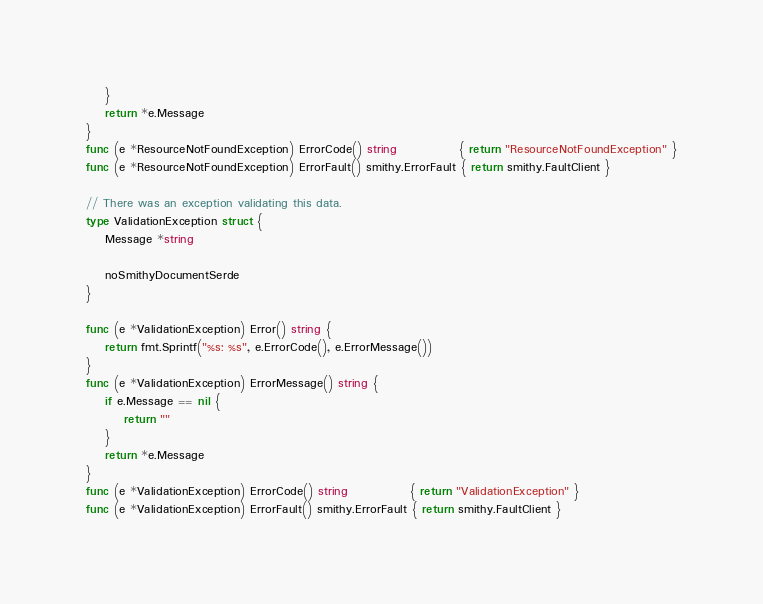<code> <loc_0><loc_0><loc_500><loc_500><_Go_>	}
	return *e.Message
}
func (e *ResourceNotFoundException) ErrorCode() string             { return "ResourceNotFoundException" }
func (e *ResourceNotFoundException) ErrorFault() smithy.ErrorFault { return smithy.FaultClient }

// There was an exception validating this data.
type ValidationException struct {
	Message *string

	noSmithyDocumentSerde
}

func (e *ValidationException) Error() string {
	return fmt.Sprintf("%s: %s", e.ErrorCode(), e.ErrorMessage())
}
func (e *ValidationException) ErrorMessage() string {
	if e.Message == nil {
		return ""
	}
	return *e.Message
}
func (e *ValidationException) ErrorCode() string             { return "ValidationException" }
func (e *ValidationException) ErrorFault() smithy.ErrorFault { return smithy.FaultClient }
</code> 